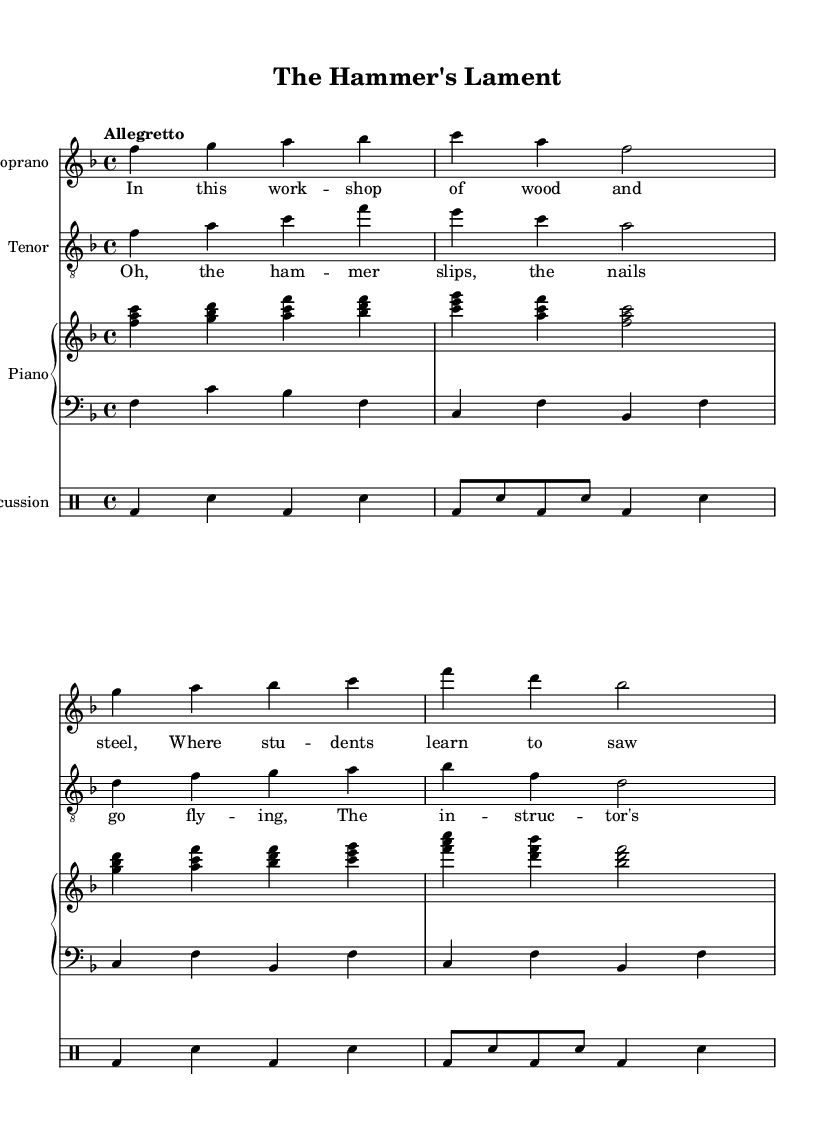What is the key signature of this music? The key signature is indicated at the beginning of the staff, which shows one flat. This means it is in F major, as F major has one flat (B flat).
Answer: F major What is the time signature of the piece? The time signature is displayed at the beginning of the music, indicated by "4/4". This means there are four beats in each measure and the quarter note gets one beat.
Answer: 4/4 What is the tempo marking of the music? The tempo marking "Allegretto" is located at the beginning of the score. This indicates a moderately fast tempo.
Answer: Allegretto How many measures are in the soprano part? The soprano part consists of eight measures, as can be counted by looking at the vertical lines that separate the measures.
Answer: Eight measures What is the highest note in the soprano part? By reviewing the soprano line, the highest note found is C in the second octave, which is the highest labeled note appearing in the part.
Answer: C What type of lyrics are used in this opera? The lyrics feature comedic themes surrounding mishaps found in a vocational school workshop, reflecting humor and a light-hearted character typical of comedic operas.
Answer: Comedic What is the primary theme of the chorus? The chorus lyrics suggest that the main theme revolves around trouble in the workshop, with references to mishaps such as slipping hammers and instructors sighing, capturing the comedic essence of the opera.
Answer: Mishaps in the workshop 